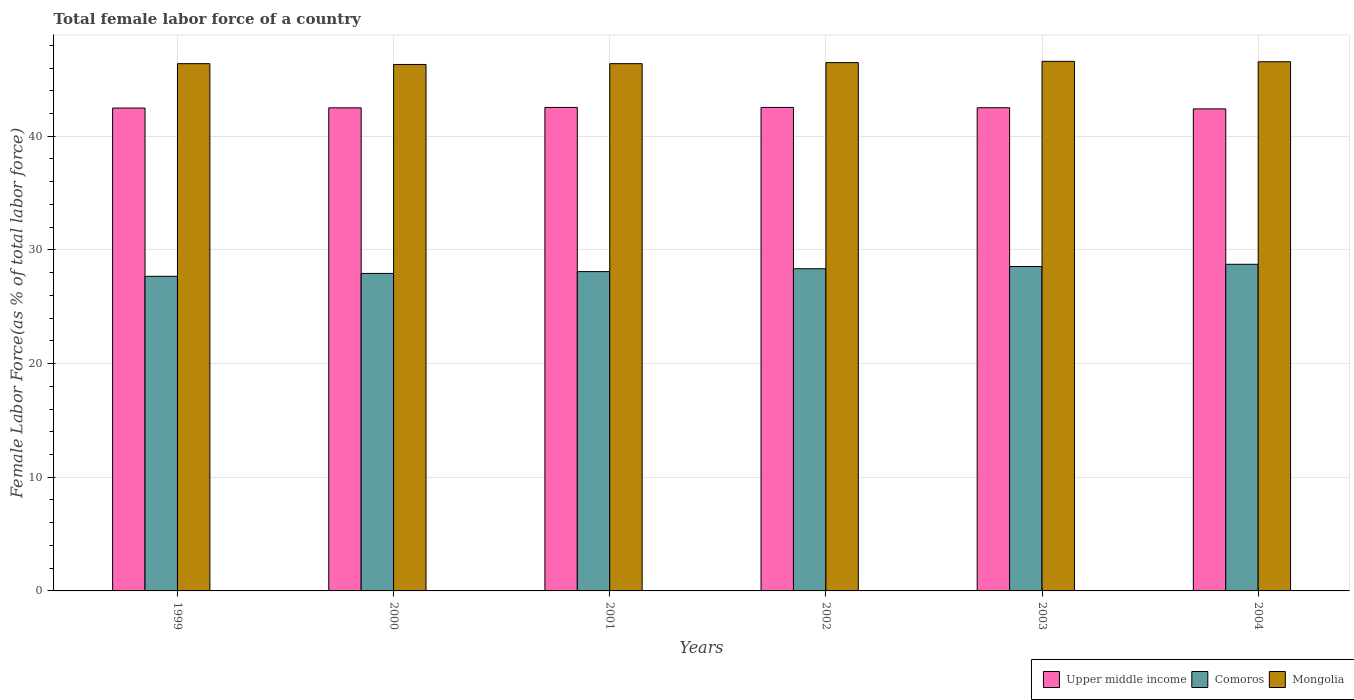Are the number of bars per tick equal to the number of legend labels?
Offer a very short reply. Yes. How many bars are there on the 1st tick from the left?
Your answer should be very brief. 3. How many bars are there on the 4th tick from the right?
Your answer should be very brief. 3. What is the label of the 4th group of bars from the left?
Ensure brevity in your answer.  2002. In how many cases, is the number of bars for a given year not equal to the number of legend labels?
Offer a very short reply. 0. What is the percentage of female labor force in Upper middle income in 2004?
Ensure brevity in your answer.  42.41. Across all years, what is the maximum percentage of female labor force in Comoros?
Your response must be concise. 28.73. Across all years, what is the minimum percentage of female labor force in Mongolia?
Offer a terse response. 46.31. In which year was the percentage of female labor force in Mongolia maximum?
Make the answer very short. 2003. In which year was the percentage of female labor force in Comoros minimum?
Keep it short and to the point. 1999. What is the total percentage of female labor force in Comoros in the graph?
Ensure brevity in your answer.  169.32. What is the difference between the percentage of female labor force in Upper middle income in 2000 and that in 2004?
Make the answer very short. 0.09. What is the difference between the percentage of female labor force in Mongolia in 2000 and the percentage of female labor force in Upper middle income in 2001?
Provide a short and direct response. 3.78. What is the average percentage of female labor force in Mongolia per year?
Offer a terse response. 46.45. In the year 2000, what is the difference between the percentage of female labor force in Mongolia and percentage of female labor force in Upper middle income?
Offer a very short reply. 3.81. In how many years, is the percentage of female labor force in Upper middle income greater than 18 %?
Your answer should be very brief. 6. What is the ratio of the percentage of female labor force in Comoros in 2002 to that in 2004?
Ensure brevity in your answer.  0.99. Is the percentage of female labor force in Mongolia in 2000 less than that in 2001?
Provide a short and direct response. Yes. Is the difference between the percentage of female labor force in Mongolia in 2001 and 2003 greater than the difference between the percentage of female labor force in Upper middle income in 2001 and 2003?
Give a very brief answer. No. What is the difference between the highest and the second highest percentage of female labor force in Upper middle income?
Your answer should be compact. 0. What is the difference between the highest and the lowest percentage of female labor force in Upper middle income?
Offer a very short reply. 0.13. What does the 2nd bar from the left in 2001 represents?
Give a very brief answer. Comoros. What does the 1st bar from the right in 1999 represents?
Provide a short and direct response. Mongolia. How many bars are there?
Your answer should be compact. 18. What is the difference between two consecutive major ticks on the Y-axis?
Provide a succinct answer. 10. How are the legend labels stacked?
Give a very brief answer. Horizontal. What is the title of the graph?
Provide a succinct answer. Total female labor force of a country. Does "Senegal" appear as one of the legend labels in the graph?
Offer a terse response. No. What is the label or title of the X-axis?
Make the answer very short. Years. What is the label or title of the Y-axis?
Keep it short and to the point. Female Labor Force(as % of total labor force). What is the Female Labor Force(as % of total labor force) of Upper middle income in 1999?
Keep it short and to the point. 42.48. What is the Female Labor Force(as % of total labor force) in Comoros in 1999?
Offer a terse response. 27.68. What is the Female Labor Force(as % of total labor force) in Mongolia in 1999?
Offer a terse response. 46.38. What is the Female Labor Force(as % of total labor force) in Upper middle income in 2000?
Keep it short and to the point. 42.5. What is the Female Labor Force(as % of total labor force) of Comoros in 2000?
Make the answer very short. 27.93. What is the Female Labor Force(as % of total labor force) of Mongolia in 2000?
Your answer should be very brief. 46.31. What is the Female Labor Force(as % of total labor force) of Upper middle income in 2001?
Your response must be concise. 42.53. What is the Female Labor Force(as % of total labor force) in Comoros in 2001?
Provide a short and direct response. 28.09. What is the Female Labor Force(as % of total labor force) of Mongolia in 2001?
Provide a short and direct response. 46.38. What is the Female Labor Force(as % of total labor force) of Upper middle income in 2002?
Make the answer very short. 42.53. What is the Female Labor Force(as % of total labor force) of Comoros in 2002?
Offer a very short reply. 28.34. What is the Female Labor Force(as % of total labor force) of Mongolia in 2002?
Offer a terse response. 46.48. What is the Female Labor Force(as % of total labor force) in Upper middle income in 2003?
Your answer should be compact. 42.51. What is the Female Labor Force(as % of total labor force) of Comoros in 2003?
Offer a very short reply. 28.54. What is the Female Labor Force(as % of total labor force) in Mongolia in 2003?
Ensure brevity in your answer.  46.59. What is the Female Labor Force(as % of total labor force) in Upper middle income in 2004?
Offer a terse response. 42.41. What is the Female Labor Force(as % of total labor force) in Comoros in 2004?
Give a very brief answer. 28.73. What is the Female Labor Force(as % of total labor force) in Mongolia in 2004?
Your answer should be compact. 46.55. Across all years, what is the maximum Female Labor Force(as % of total labor force) in Upper middle income?
Offer a terse response. 42.53. Across all years, what is the maximum Female Labor Force(as % of total labor force) in Comoros?
Make the answer very short. 28.73. Across all years, what is the maximum Female Labor Force(as % of total labor force) of Mongolia?
Provide a succinct answer. 46.59. Across all years, what is the minimum Female Labor Force(as % of total labor force) in Upper middle income?
Give a very brief answer. 42.41. Across all years, what is the minimum Female Labor Force(as % of total labor force) of Comoros?
Your answer should be compact. 27.68. Across all years, what is the minimum Female Labor Force(as % of total labor force) of Mongolia?
Your answer should be compact. 46.31. What is the total Female Labor Force(as % of total labor force) in Upper middle income in the graph?
Offer a very short reply. 254.96. What is the total Female Labor Force(as % of total labor force) of Comoros in the graph?
Your answer should be very brief. 169.32. What is the total Female Labor Force(as % of total labor force) in Mongolia in the graph?
Provide a succinct answer. 278.7. What is the difference between the Female Labor Force(as % of total labor force) in Upper middle income in 1999 and that in 2000?
Provide a succinct answer. -0.02. What is the difference between the Female Labor Force(as % of total labor force) of Comoros in 1999 and that in 2000?
Offer a very short reply. -0.25. What is the difference between the Female Labor Force(as % of total labor force) of Mongolia in 1999 and that in 2000?
Give a very brief answer. 0.07. What is the difference between the Female Labor Force(as % of total labor force) of Upper middle income in 1999 and that in 2001?
Make the answer very short. -0.05. What is the difference between the Female Labor Force(as % of total labor force) of Comoros in 1999 and that in 2001?
Your answer should be very brief. -0.41. What is the difference between the Female Labor Force(as % of total labor force) of Mongolia in 1999 and that in 2001?
Make the answer very short. 0. What is the difference between the Female Labor Force(as % of total labor force) of Upper middle income in 1999 and that in 2002?
Offer a terse response. -0.05. What is the difference between the Female Labor Force(as % of total labor force) of Comoros in 1999 and that in 2002?
Ensure brevity in your answer.  -0.66. What is the difference between the Female Labor Force(as % of total labor force) in Mongolia in 1999 and that in 2002?
Make the answer very short. -0.09. What is the difference between the Female Labor Force(as % of total labor force) of Upper middle income in 1999 and that in 2003?
Keep it short and to the point. -0.03. What is the difference between the Female Labor Force(as % of total labor force) in Comoros in 1999 and that in 2003?
Offer a very short reply. -0.86. What is the difference between the Female Labor Force(as % of total labor force) in Mongolia in 1999 and that in 2003?
Ensure brevity in your answer.  -0.2. What is the difference between the Female Labor Force(as % of total labor force) of Upper middle income in 1999 and that in 2004?
Ensure brevity in your answer.  0.07. What is the difference between the Female Labor Force(as % of total labor force) in Comoros in 1999 and that in 2004?
Your response must be concise. -1.06. What is the difference between the Female Labor Force(as % of total labor force) in Mongolia in 1999 and that in 2004?
Provide a succinct answer. -0.17. What is the difference between the Female Labor Force(as % of total labor force) in Upper middle income in 2000 and that in 2001?
Your answer should be compact. -0.03. What is the difference between the Female Labor Force(as % of total labor force) of Comoros in 2000 and that in 2001?
Your answer should be compact. -0.16. What is the difference between the Female Labor Force(as % of total labor force) of Mongolia in 2000 and that in 2001?
Your answer should be compact. -0.07. What is the difference between the Female Labor Force(as % of total labor force) of Upper middle income in 2000 and that in 2002?
Make the answer very short. -0.03. What is the difference between the Female Labor Force(as % of total labor force) of Comoros in 2000 and that in 2002?
Give a very brief answer. -0.41. What is the difference between the Female Labor Force(as % of total labor force) in Mongolia in 2000 and that in 2002?
Make the answer very short. -0.16. What is the difference between the Female Labor Force(as % of total labor force) of Upper middle income in 2000 and that in 2003?
Offer a terse response. -0.01. What is the difference between the Female Labor Force(as % of total labor force) of Comoros in 2000 and that in 2003?
Your answer should be compact. -0.61. What is the difference between the Female Labor Force(as % of total labor force) of Mongolia in 2000 and that in 2003?
Your answer should be compact. -0.27. What is the difference between the Female Labor Force(as % of total labor force) of Upper middle income in 2000 and that in 2004?
Make the answer very short. 0.09. What is the difference between the Female Labor Force(as % of total labor force) in Comoros in 2000 and that in 2004?
Provide a short and direct response. -0.8. What is the difference between the Female Labor Force(as % of total labor force) in Mongolia in 2000 and that in 2004?
Make the answer very short. -0.24. What is the difference between the Female Labor Force(as % of total labor force) in Upper middle income in 2001 and that in 2002?
Offer a very short reply. -0. What is the difference between the Female Labor Force(as % of total labor force) in Comoros in 2001 and that in 2002?
Offer a very short reply. -0.25. What is the difference between the Female Labor Force(as % of total labor force) in Mongolia in 2001 and that in 2002?
Ensure brevity in your answer.  -0.09. What is the difference between the Female Labor Force(as % of total labor force) in Upper middle income in 2001 and that in 2003?
Provide a short and direct response. 0.03. What is the difference between the Female Labor Force(as % of total labor force) in Comoros in 2001 and that in 2003?
Provide a short and direct response. -0.45. What is the difference between the Female Labor Force(as % of total labor force) of Mongolia in 2001 and that in 2003?
Offer a terse response. -0.2. What is the difference between the Female Labor Force(as % of total labor force) of Upper middle income in 2001 and that in 2004?
Offer a very short reply. 0.13. What is the difference between the Female Labor Force(as % of total labor force) in Comoros in 2001 and that in 2004?
Provide a succinct answer. -0.64. What is the difference between the Female Labor Force(as % of total labor force) in Mongolia in 2001 and that in 2004?
Offer a terse response. -0.17. What is the difference between the Female Labor Force(as % of total labor force) in Upper middle income in 2002 and that in 2003?
Make the answer very short. 0.03. What is the difference between the Female Labor Force(as % of total labor force) of Comoros in 2002 and that in 2003?
Make the answer very short. -0.2. What is the difference between the Female Labor Force(as % of total labor force) in Mongolia in 2002 and that in 2003?
Make the answer very short. -0.11. What is the difference between the Female Labor Force(as % of total labor force) of Upper middle income in 2002 and that in 2004?
Offer a very short reply. 0.13. What is the difference between the Female Labor Force(as % of total labor force) in Comoros in 2002 and that in 2004?
Provide a short and direct response. -0.39. What is the difference between the Female Labor Force(as % of total labor force) of Mongolia in 2002 and that in 2004?
Provide a succinct answer. -0.07. What is the difference between the Female Labor Force(as % of total labor force) of Upper middle income in 2003 and that in 2004?
Ensure brevity in your answer.  0.1. What is the difference between the Female Labor Force(as % of total labor force) of Comoros in 2003 and that in 2004?
Your answer should be very brief. -0.2. What is the difference between the Female Labor Force(as % of total labor force) in Mongolia in 2003 and that in 2004?
Make the answer very short. 0.04. What is the difference between the Female Labor Force(as % of total labor force) in Upper middle income in 1999 and the Female Labor Force(as % of total labor force) in Comoros in 2000?
Make the answer very short. 14.55. What is the difference between the Female Labor Force(as % of total labor force) of Upper middle income in 1999 and the Female Labor Force(as % of total labor force) of Mongolia in 2000?
Provide a succinct answer. -3.83. What is the difference between the Female Labor Force(as % of total labor force) in Comoros in 1999 and the Female Labor Force(as % of total labor force) in Mongolia in 2000?
Give a very brief answer. -18.64. What is the difference between the Female Labor Force(as % of total labor force) in Upper middle income in 1999 and the Female Labor Force(as % of total labor force) in Comoros in 2001?
Provide a short and direct response. 14.39. What is the difference between the Female Labor Force(as % of total labor force) in Upper middle income in 1999 and the Female Labor Force(as % of total labor force) in Mongolia in 2001?
Your answer should be compact. -3.91. What is the difference between the Female Labor Force(as % of total labor force) in Comoros in 1999 and the Female Labor Force(as % of total labor force) in Mongolia in 2001?
Keep it short and to the point. -18.71. What is the difference between the Female Labor Force(as % of total labor force) of Upper middle income in 1999 and the Female Labor Force(as % of total labor force) of Comoros in 2002?
Offer a terse response. 14.14. What is the difference between the Female Labor Force(as % of total labor force) of Upper middle income in 1999 and the Female Labor Force(as % of total labor force) of Mongolia in 2002?
Provide a short and direct response. -4. What is the difference between the Female Labor Force(as % of total labor force) in Comoros in 1999 and the Female Labor Force(as % of total labor force) in Mongolia in 2002?
Make the answer very short. -18.8. What is the difference between the Female Labor Force(as % of total labor force) in Upper middle income in 1999 and the Female Labor Force(as % of total labor force) in Comoros in 2003?
Offer a very short reply. 13.94. What is the difference between the Female Labor Force(as % of total labor force) in Upper middle income in 1999 and the Female Labor Force(as % of total labor force) in Mongolia in 2003?
Provide a succinct answer. -4.11. What is the difference between the Female Labor Force(as % of total labor force) in Comoros in 1999 and the Female Labor Force(as % of total labor force) in Mongolia in 2003?
Provide a succinct answer. -18.91. What is the difference between the Female Labor Force(as % of total labor force) of Upper middle income in 1999 and the Female Labor Force(as % of total labor force) of Comoros in 2004?
Keep it short and to the point. 13.74. What is the difference between the Female Labor Force(as % of total labor force) of Upper middle income in 1999 and the Female Labor Force(as % of total labor force) of Mongolia in 2004?
Keep it short and to the point. -4.07. What is the difference between the Female Labor Force(as % of total labor force) in Comoros in 1999 and the Female Labor Force(as % of total labor force) in Mongolia in 2004?
Give a very brief answer. -18.87. What is the difference between the Female Labor Force(as % of total labor force) in Upper middle income in 2000 and the Female Labor Force(as % of total labor force) in Comoros in 2001?
Offer a terse response. 14.41. What is the difference between the Female Labor Force(as % of total labor force) in Upper middle income in 2000 and the Female Labor Force(as % of total labor force) in Mongolia in 2001?
Make the answer very short. -3.89. What is the difference between the Female Labor Force(as % of total labor force) in Comoros in 2000 and the Female Labor Force(as % of total labor force) in Mongolia in 2001?
Your answer should be very brief. -18.45. What is the difference between the Female Labor Force(as % of total labor force) in Upper middle income in 2000 and the Female Labor Force(as % of total labor force) in Comoros in 2002?
Provide a short and direct response. 14.16. What is the difference between the Female Labor Force(as % of total labor force) in Upper middle income in 2000 and the Female Labor Force(as % of total labor force) in Mongolia in 2002?
Your answer should be very brief. -3.98. What is the difference between the Female Labor Force(as % of total labor force) of Comoros in 2000 and the Female Labor Force(as % of total labor force) of Mongolia in 2002?
Make the answer very short. -18.55. What is the difference between the Female Labor Force(as % of total labor force) of Upper middle income in 2000 and the Female Labor Force(as % of total labor force) of Comoros in 2003?
Offer a terse response. 13.96. What is the difference between the Female Labor Force(as % of total labor force) in Upper middle income in 2000 and the Female Labor Force(as % of total labor force) in Mongolia in 2003?
Ensure brevity in your answer.  -4.09. What is the difference between the Female Labor Force(as % of total labor force) in Comoros in 2000 and the Female Labor Force(as % of total labor force) in Mongolia in 2003?
Offer a very short reply. -18.66. What is the difference between the Female Labor Force(as % of total labor force) in Upper middle income in 2000 and the Female Labor Force(as % of total labor force) in Comoros in 2004?
Ensure brevity in your answer.  13.76. What is the difference between the Female Labor Force(as % of total labor force) of Upper middle income in 2000 and the Female Labor Force(as % of total labor force) of Mongolia in 2004?
Your response must be concise. -4.05. What is the difference between the Female Labor Force(as % of total labor force) of Comoros in 2000 and the Female Labor Force(as % of total labor force) of Mongolia in 2004?
Your response must be concise. -18.62. What is the difference between the Female Labor Force(as % of total labor force) in Upper middle income in 2001 and the Female Labor Force(as % of total labor force) in Comoros in 2002?
Your answer should be very brief. 14.19. What is the difference between the Female Labor Force(as % of total labor force) of Upper middle income in 2001 and the Female Labor Force(as % of total labor force) of Mongolia in 2002?
Provide a succinct answer. -3.95. What is the difference between the Female Labor Force(as % of total labor force) in Comoros in 2001 and the Female Labor Force(as % of total labor force) in Mongolia in 2002?
Give a very brief answer. -18.39. What is the difference between the Female Labor Force(as % of total labor force) in Upper middle income in 2001 and the Female Labor Force(as % of total labor force) in Comoros in 2003?
Ensure brevity in your answer.  13.99. What is the difference between the Female Labor Force(as % of total labor force) of Upper middle income in 2001 and the Female Labor Force(as % of total labor force) of Mongolia in 2003?
Keep it short and to the point. -4.05. What is the difference between the Female Labor Force(as % of total labor force) in Comoros in 2001 and the Female Labor Force(as % of total labor force) in Mongolia in 2003?
Provide a short and direct response. -18.5. What is the difference between the Female Labor Force(as % of total labor force) of Upper middle income in 2001 and the Female Labor Force(as % of total labor force) of Comoros in 2004?
Provide a succinct answer. 13.8. What is the difference between the Female Labor Force(as % of total labor force) of Upper middle income in 2001 and the Female Labor Force(as % of total labor force) of Mongolia in 2004?
Offer a terse response. -4.02. What is the difference between the Female Labor Force(as % of total labor force) of Comoros in 2001 and the Female Labor Force(as % of total labor force) of Mongolia in 2004?
Your response must be concise. -18.46. What is the difference between the Female Labor Force(as % of total labor force) of Upper middle income in 2002 and the Female Labor Force(as % of total labor force) of Comoros in 2003?
Your answer should be very brief. 13.99. What is the difference between the Female Labor Force(as % of total labor force) of Upper middle income in 2002 and the Female Labor Force(as % of total labor force) of Mongolia in 2003?
Your answer should be very brief. -4.05. What is the difference between the Female Labor Force(as % of total labor force) of Comoros in 2002 and the Female Labor Force(as % of total labor force) of Mongolia in 2003?
Make the answer very short. -18.24. What is the difference between the Female Labor Force(as % of total labor force) of Upper middle income in 2002 and the Female Labor Force(as % of total labor force) of Comoros in 2004?
Keep it short and to the point. 13.8. What is the difference between the Female Labor Force(as % of total labor force) in Upper middle income in 2002 and the Female Labor Force(as % of total labor force) in Mongolia in 2004?
Provide a short and direct response. -4.02. What is the difference between the Female Labor Force(as % of total labor force) in Comoros in 2002 and the Female Labor Force(as % of total labor force) in Mongolia in 2004?
Offer a terse response. -18.21. What is the difference between the Female Labor Force(as % of total labor force) in Upper middle income in 2003 and the Female Labor Force(as % of total labor force) in Comoros in 2004?
Your response must be concise. 13.77. What is the difference between the Female Labor Force(as % of total labor force) in Upper middle income in 2003 and the Female Labor Force(as % of total labor force) in Mongolia in 2004?
Ensure brevity in your answer.  -4.04. What is the difference between the Female Labor Force(as % of total labor force) of Comoros in 2003 and the Female Labor Force(as % of total labor force) of Mongolia in 2004?
Offer a terse response. -18.01. What is the average Female Labor Force(as % of total labor force) of Upper middle income per year?
Make the answer very short. 42.49. What is the average Female Labor Force(as % of total labor force) in Comoros per year?
Your answer should be compact. 28.22. What is the average Female Labor Force(as % of total labor force) in Mongolia per year?
Your response must be concise. 46.45. In the year 1999, what is the difference between the Female Labor Force(as % of total labor force) in Upper middle income and Female Labor Force(as % of total labor force) in Comoros?
Your answer should be compact. 14.8. In the year 1999, what is the difference between the Female Labor Force(as % of total labor force) in Upper middle income and Female Labor Force(as % of total labor force) in Mongolia?
Your response must be concise. -3.91. In the year 1999, what is the difference between the Female Labor Force(as % of total labor force) in Comoros and Female Labor Force(as % of total labor force) in Mongolia?
Give a very brief answer. -18.71. In the year 2000, what is the difference between the Female Labor Force(as % of total labor force) of Upper middle income and Female Labor Force(as % of total labor force) of Comoros?
Your answer should be compact. 14.57. In the year 2000, what is the difference between the Female Labor Force(as % of total labor force) in Upper middle income and Female Labor Force(as % of total labor force) in Mongolia?
Provide a succinct answer. -3.81. In the year 2000, what is the difference between the Female Labor Force(as % of total labor force) of Comoros and Female Labor Force(as % of total labor force) of Mongolia?
Ensure brevity in your answer.  -18.38. In the year 2001, what is the difference between the Female Labor Force(as % of total labor force) in Upper middle income and Female Labor Force(as % of total labor force) in Comoros?
Offer a very short reply. 14.44. In the year 2001, what is the difference between the Female Labor Force(as % of total labor force) in Upper middle income and Female Labor Force(as % of total labor force) in Mongolia?
Offer a terse response. -3.85. In the year 2001, what is the difference between the Female Labor Force(as % of total labor force) in Comoros and Female Labor Force(as % of total labor force) in Mongolia?
Keep it short and to the point. -18.29. In the year 2002, what is the difference between the Female Labor Force(as % of total labor force) of Upper middle income and Female Labor Force(as % of total labor force) of Comoros?
Your answer should be compact. 14.19. In the year 2002, what is the difference between the Female Labor Force(as % of total labor force) in Upper middle income and Female Labor Force(as % of total labor force) in Mongolia?
Offer a very short reply. -3.94. In the year 2002, what is the difference between the Female Labor Force(as % of total labor force) in Comoros and Female Labor Force(as % of total labor force) in Mongolia?
Your answer should be very brief. -18.14. In the year 2003, what is the difference between the Female Labor Force(as % of total labor force) of Upper middle income and Female Labor Force(as % of total labor force) of Comoros?
Ensure brevity in your answer.  13.97. In the year 2003, what is the difference between the Female Labor Force(as % of total labor force) in Upper middle income and Female Labor Force(as % of total labor force) in Mongolia?
Your response must be concise. -4.08. In the year 2003, what is the difference between the Female Labor Force(as % of total labor force) of Comoros and Female Labor Force(as % of total labor force) of Mongolia?
Ensure brevity in your answer.  -18.05. In the year 2004, what is the difference between the Female Labor Force(as % of total labor force) in Upper middle income and Female Labor Force(as % of total labor force) in Comoros?
Provide a short and direct response. 13.67. In the year 2004, what is the difference between the Female Labor Force(as % of total labor force) of Upper middle income and Female Labor Force(as % of total labor force) of Mongolia?
Your answer should be compact. -4.15. In the year 2004, what is the difference between the Female Labor Force(as % of total labor force) in Comoros and Female Labor Force(as % of total labor force) in Mongolia?
Give a very brief answer. -17.82. What is the ratio of the Female Labor Force(as % of total labor force) of Upper middle income in 1999 to that in 2000?
Your response must be concise. 1. What is the ratio of the Female Labor Force(as % of total labor force) in Upper middle income in 1999 to that in 2001?
Make the answer very short. 1. What is the ratio of the Female Labor Force(as % of total labor force) in Mongolia in 1999 to that in 2001?
Your answer should be very brief. 1. What is the ratio of the Female Labor Force(as % of total labor force) of Comoros in 1999 to that in 2002?
Ensure brevity in your answer.  0.98. What is the ratio of the Female Labor Force(as % of total labor force) of Upper middle income in 1999 to that in 2003?
Provide a succinct answer. 1. What is the ratio of the Female Labor Force(as % of total labor force) of Comoros in 1999 to that in 2003?
Offer a terse response. 0.97. What is the ratio of the Female Labor Force(as % of total labor force) in Comoros in 1999 to that in 2004?
Your answer should be compact. 0.96. What is the ratio of the Female Labor Force(as % of total labor force) in Comoros in 2000 to that in 2001?
Provide a succinct answer. 0.99. What is the ratio of the Female Labor Force(as % of total labor force) in Mongolia in 2000 to that in 2001?
Provide a succinct answer. 1. What is the ratio of the Female Labor Force(as % of total labor force) of Upper middle income in 2000 to that in 2002?
Your response must be concise. 1. What is the ratio of the Female Labor Force(as % of total labor force) of Comoros in 2000 to that in 2002?
Offer a terse response. 0.99. What is the ratio of the Female Labor Force(as % of total labor force) in Upper middle income in 2000 to that in 2003?
Your answer should be very brief. 1. What is the ratio of the Female Labor Force(as % of total labor force) in Comoros in 2000 to that in 2003?
Offer a very short reply. 0.98. What is the ratio of the Female Labor Force(as % of total labor force) in Upper middle income in 2000 to that in 2004?
Your answer should be very brief. 1. What is the ratio of the Female Labor Force(as % of total labor force) of Comoros in 2000 to that in 2004?
Your response must be concise. 0.97. What is the ratio of the Female Labor Force(as % of total labor force) of Mongolia in 2000 to that in 2004?
Provide a short and direct response. 0.99. What is the ratio of the Female Labor Force(as % of total labor force) in Upper middle income in 2001 to that in 2002?
Ensure brevity in your answer.  1. What is the ratio of the Female Labor Force(as % of total labor force) of Comoros in 2001 to that in 2002?
Your response must be concise. 0.99. What is the ratio of the Female Labor Force(as % of total labor force) in Mongolia in 2001 to that in 2002?
Your response must be concise. 1. What is the ratio of the Female Labor Force(as % of total labor force) of Upper middle income in 2001 to that in 2003?
Your answer should be compact. 1. What is the ratio of the Female Labor Force(as % of total labor force) of Comoros in 2001 to that in 2003?
Ensure brevity in your answer.  0.98. What is the ratio of the Female Labor Force(as % of total labor force) in Upper middle income in 2001 to that in 2004?
Give a very brief answer. 1. What is the ratio of the Female Labor Force(as % of total labor force) of Comoros in 2001 to that in 2004?
Your response must be concise. 0.98. What is the ratio of the Female Labor Force(as % of total labor force) in Upper middle income in 2002 to that in 2003?
Keep it short and to the point. 1. What is the ratio of the Female Labor Force(as % of total labor force) of Comoros in 2002 to that in 2004?
Your response must be concise. 0.99. What is the ratio of the Female Labor Force(as % of total labor force) of Comoros in 2003 to that in 2004?
Provide a short and direct response. 0.99. What is the ratio of the Female Labor Force(as % of total labor force) in Mongolia in 2003 to that in 2004?
Keep it short and to the point. 1. What is the difference between the highest and the second highest Female Labor Force(as % of total labor force) in Upper middle income?
Your answer should be compact. 0. What is the difference between the highest and the second highest Female Labor Force(as % of total labor force) in Comoros?
Ensure brevity in your answer.  0.2. What is the difference between the highest and the second highest Female Labor Force(as % of total labor force) of Mongolia?
Offer a very short reply. 0.04. What is the difference between the highest and the lowest Female Labor Force(as % of total labor force) in Upper middle income?
Keep it short and to the point. 0.13. What is the difference between the highest and the lowest Female Labor Force(as % of total labor force) in Comoros?
Offer a very short reply. 1.06. What is the difference between the highest and the lowest Female Labor Force(as % of total labor force) in Mongolia?
Make the answer very short. 0.27. 